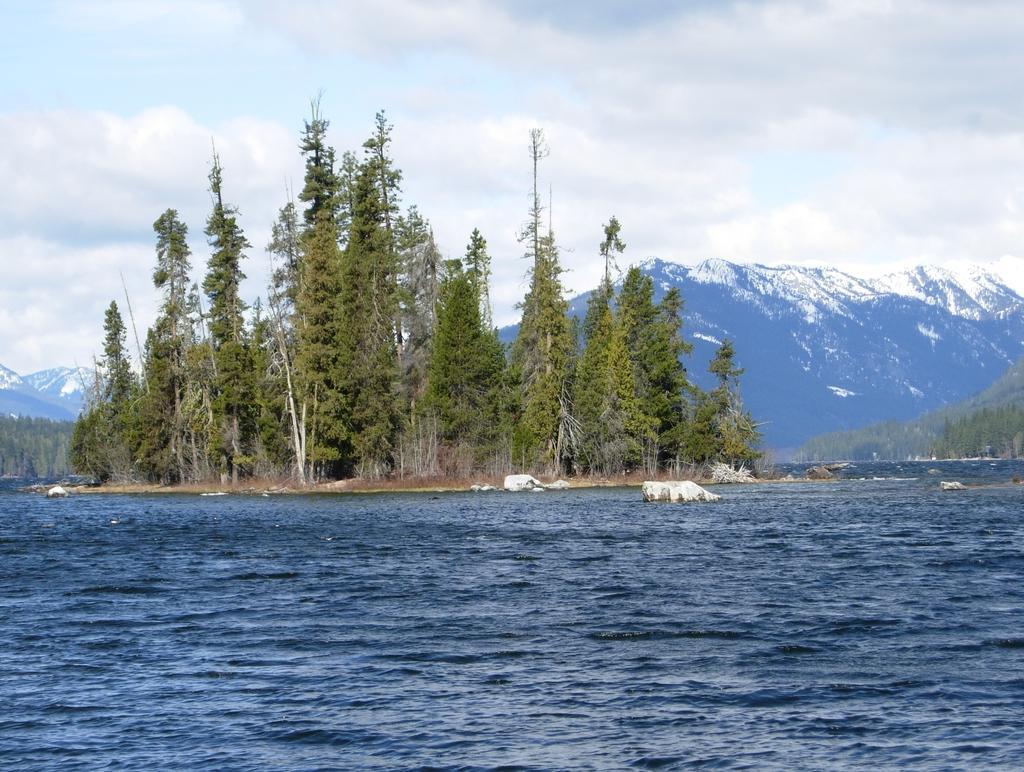Please provide a concise description of this image. This is completely an outdoor picture. On the background of the picture we can see clouds. These are the mountains with peaks. These are the trees. This is a sea with fresh blue water. This is a stone in the middle of the sea. 